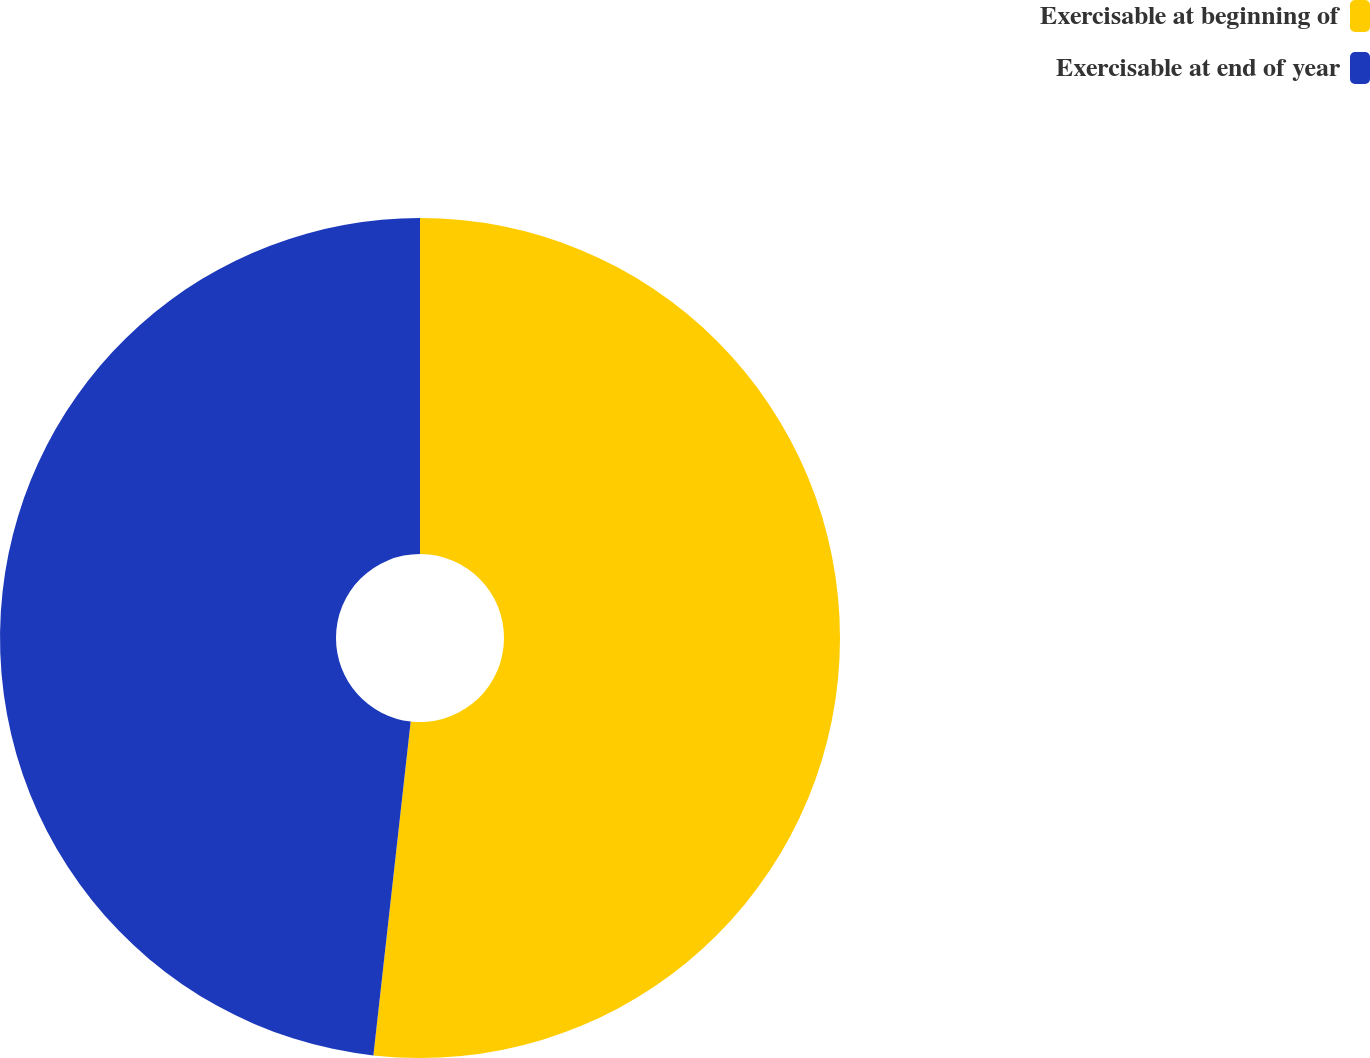Convert chart to OTSL. <chart><loc_0><loc_0><loc_500><loc_500><pie_chart><fcel>Exercisable at beginning of<fcel>Exercisable at end of year<nl><fcel>51.77%<fcel>48.23%<nl></chart> 